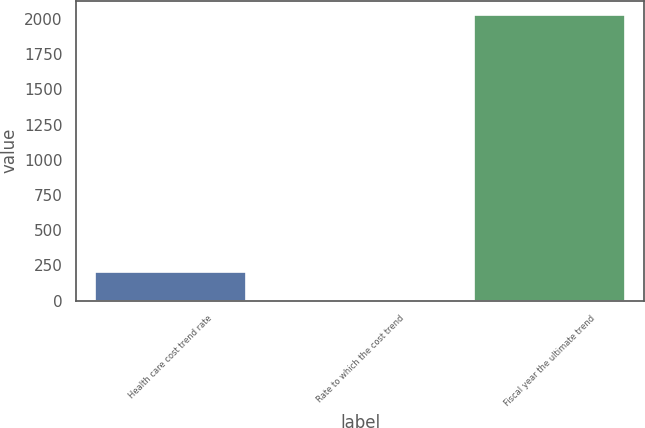Convert chart to OTSL. <chart><loc_0><loc_0><loc_500><loc_500><bar_chart><fcel>Health care cost trend rate<fcel>Rate to which the cost trend<fcel>Fiscal year the ultimate trend<nl><fcel>206.95<fcel>4.5<fcel>2029<nl></chart> 